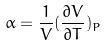Convert formula to latex. <formula><loc_0><loc_0><loc_500><loc_500>\alpha = \frac { 1 } { V } ( \frac { \partial V } { \partial T } ) _ { P }</formula> 